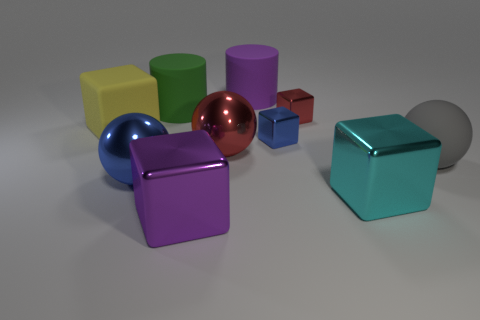What number of other things are the same size as the red block?
Offer a very short reply. 1. Are there the same number of green rubber objects that are right of the purple rubber cylinder and red things?
Make the answer very short. No. There is a big matte cylinder that is on the right side of the big purple cube; is its color the same as the big matte object that is to the right of the large cyan thing?
Provide a short and direct response. No. What is the big thing that is behind the large red metal object and in front of the large green cylinder made of?
Provide a succinct answer. Rubber. The rubber ball has what color?
Give a very brief answer. Gray. How many other things are there of the same shape as the big purple matte object?
Keep it short and to the point. 1. Are there the same number of large red metal spheres that are in front of the cyan block and small blue cubes to the left of the big red ball?
Your answer should be very brief. Yes. What is the big purple block made of?
Offer a terse response. Metal. What is the large block that is behind the big gray rubber ball made of?
Keep it short and to the point. Rubber. Is the number of gray rubber objects that are in front of the green rubber object greater than the number of gray metal blocks?
Provide a succinct answer. Yes. 